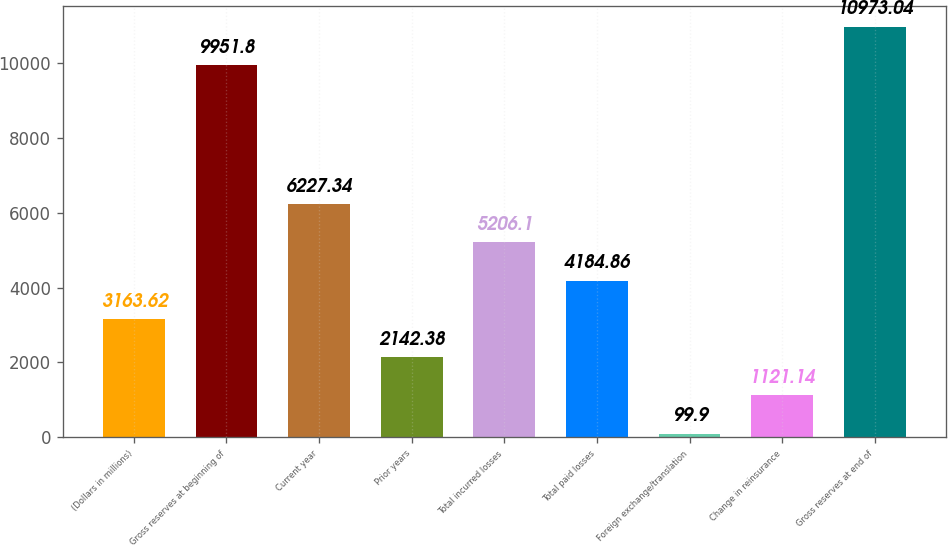<chart> <loc_0><loc_0><loc_500><loc_500><bar_chart><fcel>(Dollars in millions)<fcel>Gross reserves at beginning of<fcel>Current year<fcel>Prior years<fcel>Total incurred losses<fcel>Total paid losses<fcel>Foreign exchange/translation<fcel>Change in reinsurance<fcel>Gross reserves at end of<nl><fcel>3163.62<fcel>9951.8<fcel>6227.34<fcel>2142.38<fcel>5206.1<fcel>4184.86<fcel>99.9<fcel>1121.14<fcel>10973<nl></chart> 